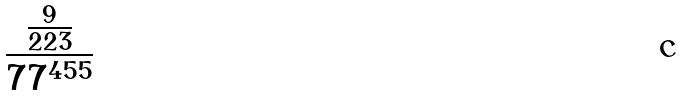<formula> <loc_0><loc_0><loc_500><loc_500>\frac { \frac { 9 } { 2 2 3 } } { 7 7 ^ { 4 5 5 } }</formula> 